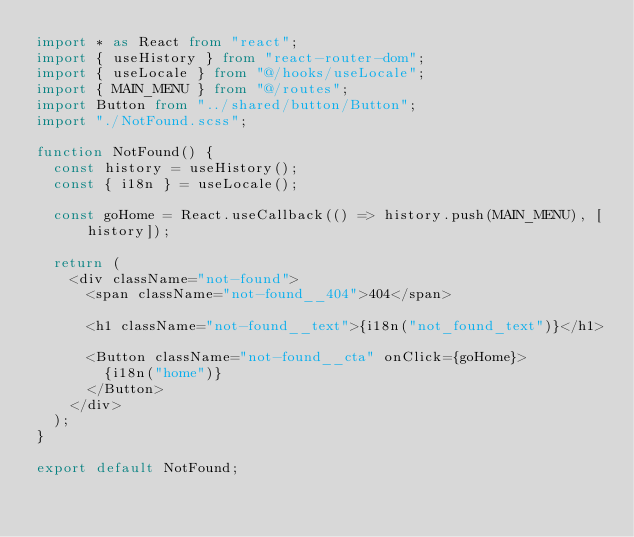<code> <loc_0><loc_0><loc_500><loc_500><_TypeScript_>import * as React from "react";
import { useHistory } from "react-router-dom";
import { useLocale } from "@/hooks/useLocale";
import { MAIN_MENU } from "@/routes";
import Button from "../shared/button/Button";
import "./NotFound.scss";

function NotFound() {
  const history = useHistory();
  const { i18n } = useLocale();

  const goHome = React.useCallback(() => history.push(MAIN_MENU), [history]);

  return (
    <div className="not-found">
      <span className="not-found__404">404</span>

      <h1 className="not-found__text">{i18n("not_found_text")}</h1>

      <Button className="not-found__cta" onClick={goHome}>
        {i18n("home")}
      </Button>
    </div>
  );
}

export default NotFound;
</code> 